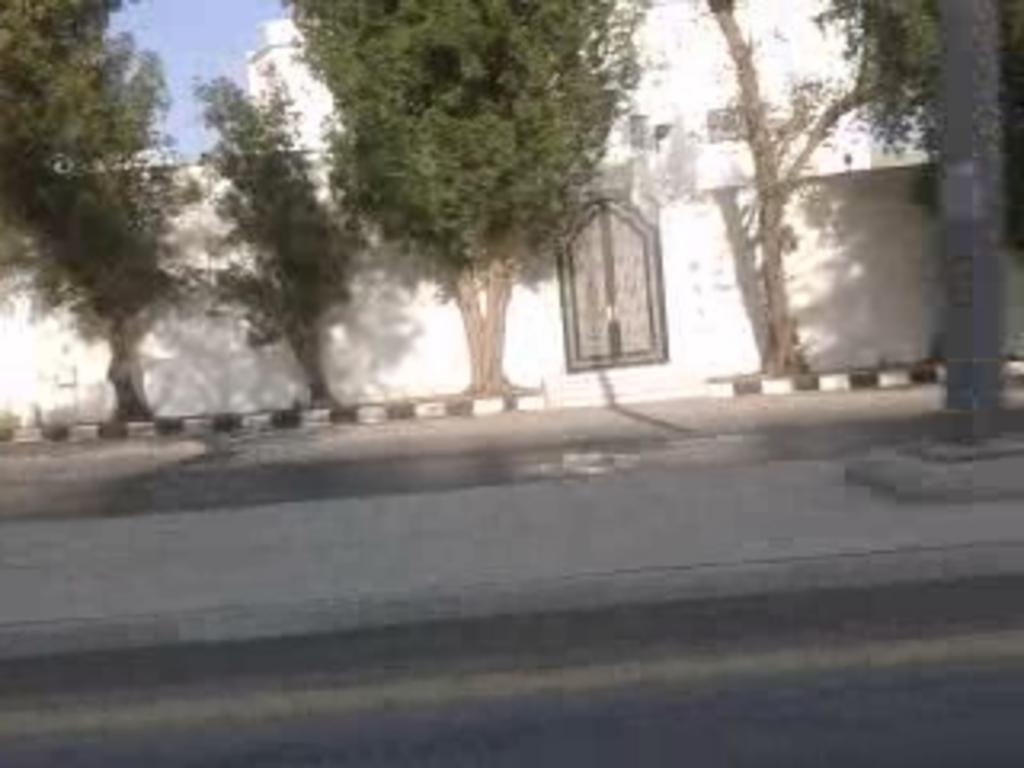What type of natural elements can be seen in the image? There are trees in the image. What type of man-made structures are present in the image? There are buildings in the image. What object can be seen on the right side of the image? There is a pole on the right side of the image. Can you tell me the position of the maid in the image? There is no maid present in the image. What type of poison is being used by the trees in the image? There is no mention of poison or any toxic substance in the image; the trees are natural elements. 